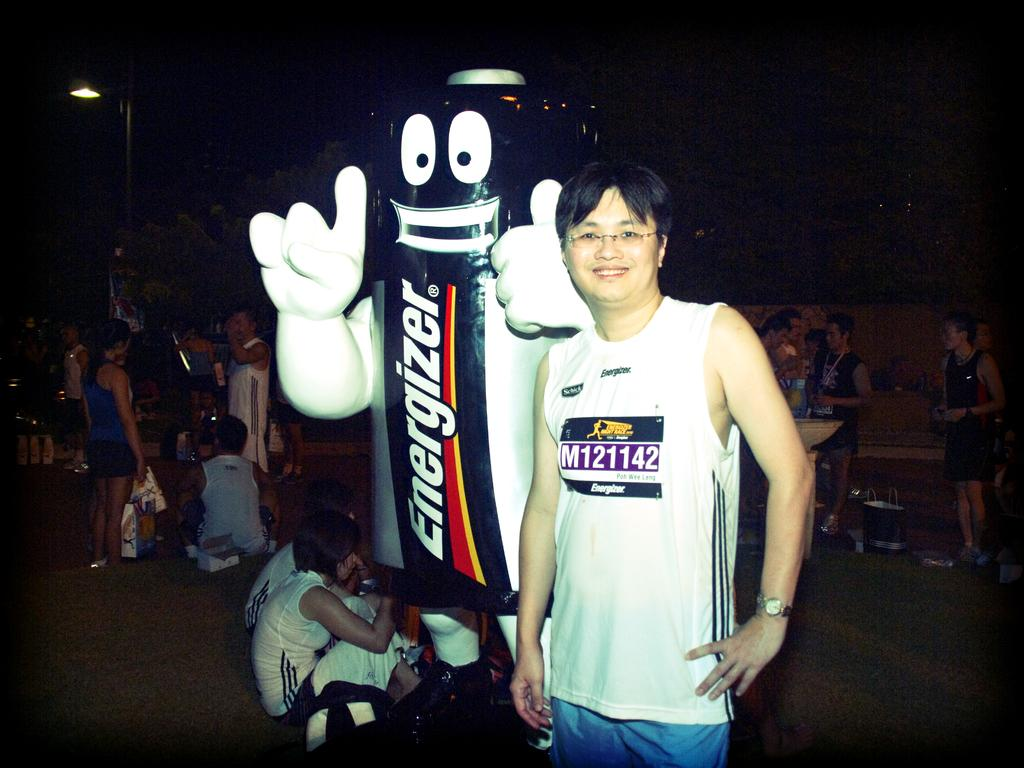<image>
Provide a brief description of the given image. A man stands next to someone in an Energizer battery costume. 